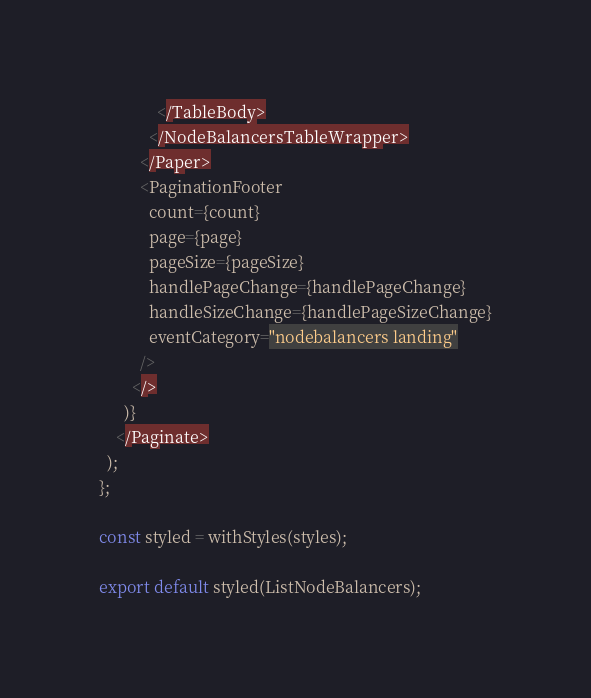Convert code to text. <code><loc_0><loc_0><loc_500><loc_500><_TypeScript_>              </TableBody>
            </NodeBalancersTableWrapper>
          </Paper>
          <PaginationFooter
            count={count}
            page={page}
            pageSize={pageSize}
            handlePageChange={handlePageChange}
            handleSizeChange={handlePageSizeChange}
            eventCategory="nodebalancers landing"
          />
        </>
      )}
    </Paginate>
  );
};

const styled = withStyles(styles);

export default styled(ListNodeBalancers);
</code> 